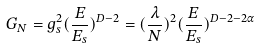Convert formula to latex. <formula><loc_0><loc_0><loc_500><loc_500>G _ { N } = g _ { s } ^ { 2 } ( \frac { E } { E _ { s } } ) ^ { D - 2 } = ( \frac { \lambda } { N } ) ^ { 2 } ( \frac { E } { E _ { s } } ) ^ { D - 2 - 2 \alpha }</formula> 